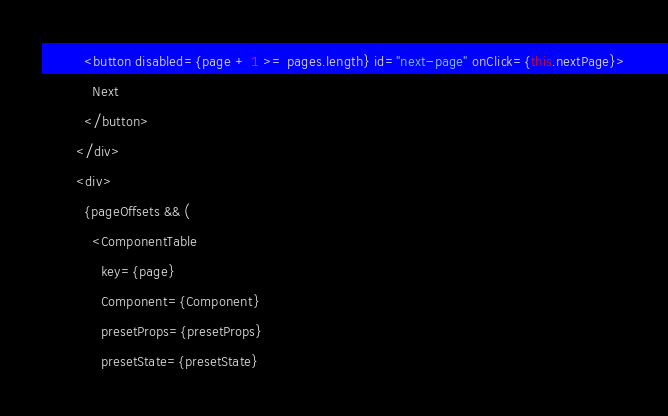Convert code to text. <code><loc_0><loc_0><loc_500><loc_500><_TypeScript_>          <button disabled={page + 1 >= pages.length} id="next-page" onClick={this.nextPage}>
            Next
          </button>
        </div>
        <div>
          {pageOffsets && (
            <ComponentTable
              key={page}
              Component={Component}
              presetProps={presetProps}
              presetState={presetState}</code> 